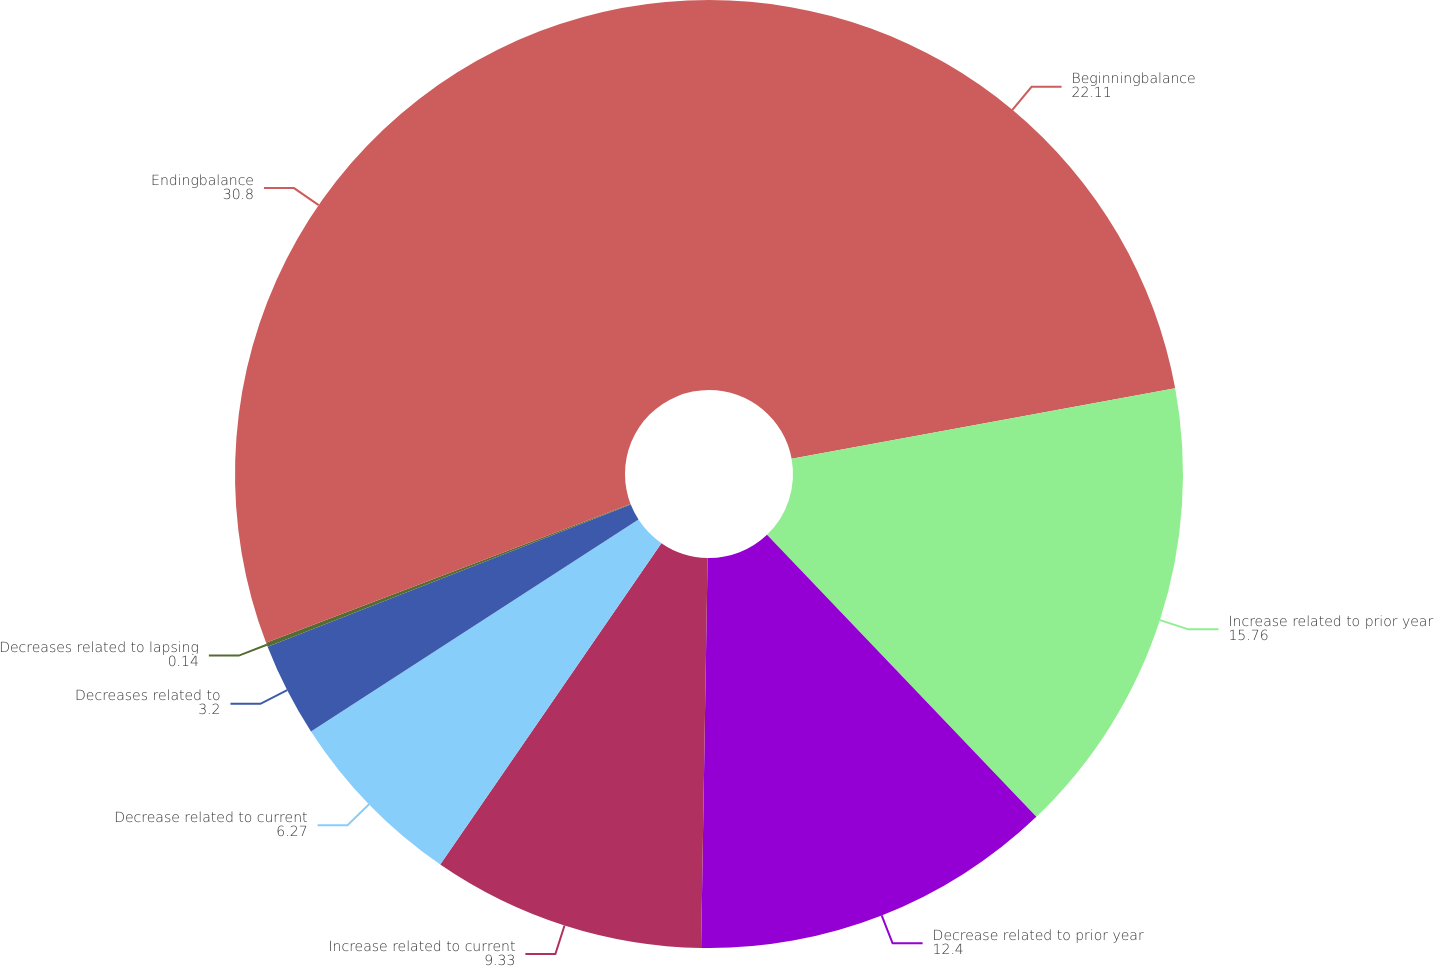<chart> <loc_0><loc_0><loc_500><loc_500><pie_chart><fcel>Beginningbalance<fcel>Increase related to prior year<fcel>Decrease related to prior year<fcel>Increase related to current<fcel>Decrease related to current<fcel>Decreases related to<fcel>Decreases related to lapsing<fcel>Endingbalance<nl><fcel>22.11%<fcel>15.76%<fcel>12.4%<fcel>9.33%<fcel>6.27%<fcel>3.2%<fcel>0.14%<fcel>30.8%<nl></chart> 